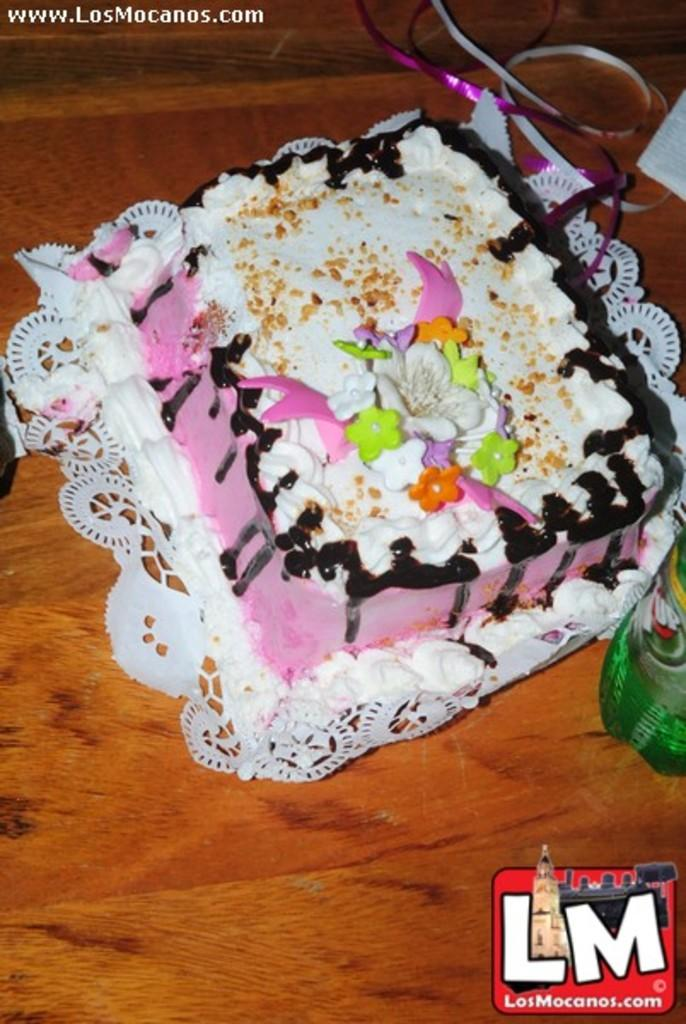What type of dessert is featured in the image? There is a cake with cream in the image. What kind of cream is used on the cake? The cake has chocolate cream. Where is the cake located in the image? The cake is placed on a table. What decorative items are present on the table? There are ribbons on the table. What functional items are present on the table? There are tissues and a bottle on the table. What emotion is the cake expressing in the image? Cakes do not express emotions, so this question cannot be answered. 